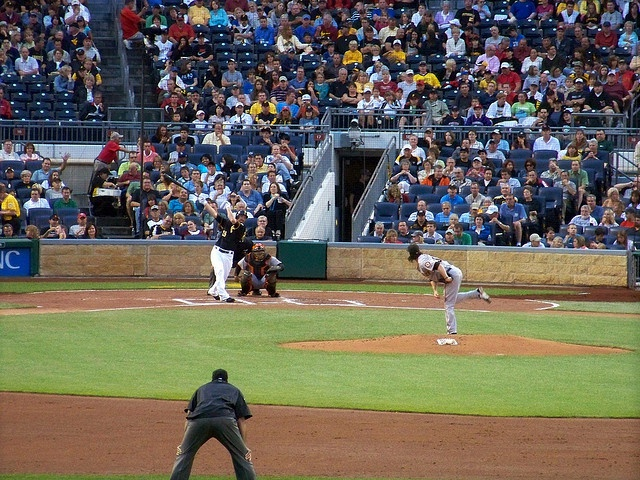Describe the objects in this image and their specific colors. I can see people in black, gray, navy, and maroon tones, chair in black, navy, gray, and darkblue tones, people in black, gray, and darkblue tones, people in black, white, gray, and darkgray tones, and people in black, darkgray, lightgray, and gray tones in this image. 